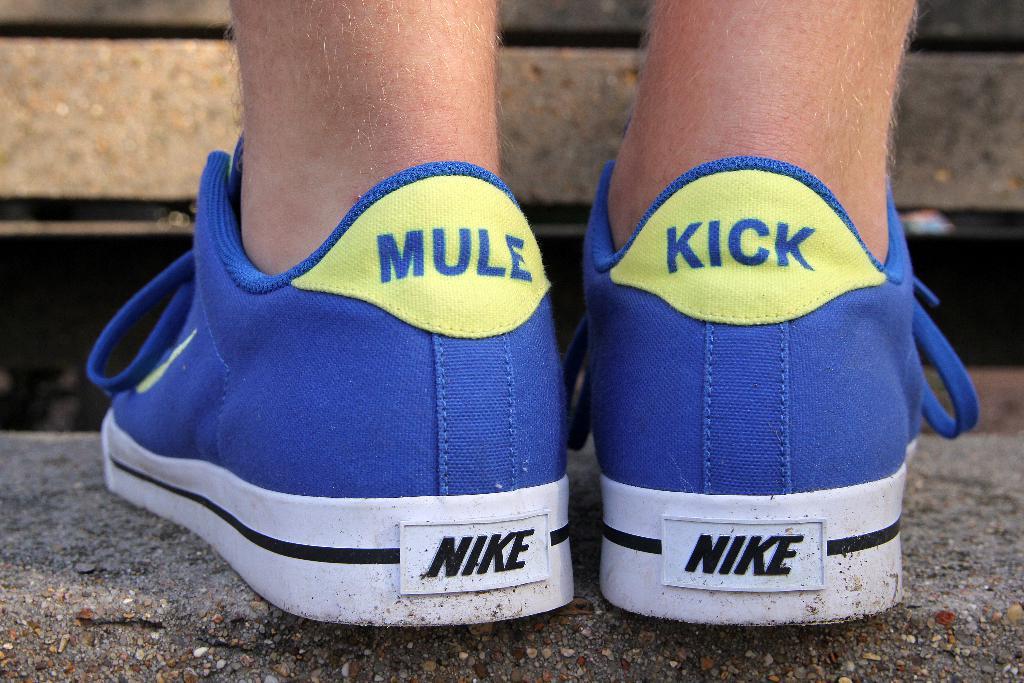What brand shoe is this?
Offer a very short reply. Nike. 